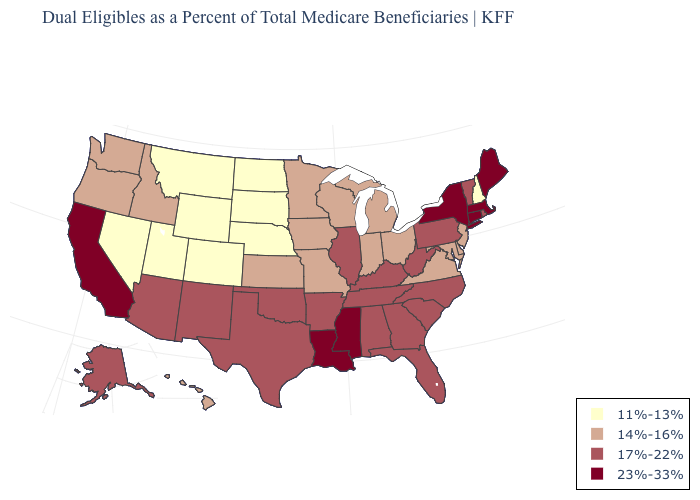Does North Carolina have a lower value than California?
Quick response, please. Yes. What is the value of Indiana?
Concise answer only. 14%-16%. Among the states that border Kansas , which have the lowest value?
Concise answer only. Colorado, Nebraska. Name the states that have a value in the range 17%-22%?
Answer briefly. Alabama, Alaska, Arizona, Arkansas, Florida, Georgia, Illinois, Kentucky, New Mexico, North Carolina, Oklahoma, Pennsylvania, Rhode Island, South Carolina, Tennessee, Texas, Vermont, West Virginia. What is the highest value in the Northeast ?
Short answer required. 23%-33%. What is the lowest value in the MidWest?
Short answer required. 11%-13%. Does New Hampshire have a lower value than Missouri?
Concise answer only. Yes. Which states have the highest value in the USA?
Write a very short answer. California, Connecticut, Louisiana, Maine, Massachusetts, Mississippi, New York. Does Idaho have the highest value in the USA?
Write a very short answer. No. Among the states that border Kansas , which have the lowest value?
Quick response, please. Colorado, Nebraska. Does Oklahoma have the same value as South Carolina?
Write a very short answer. Yes. What is the highest value in the USA?
Answer briefly. 23%-33%. Which states hav the highest value in the MidWest?
Give a very brief answer. Illinois. Does Delaware have a higher value than Utah?
Quick response, please. Yes. Name the states that have a value in the range 14%-16%?
Answer briefly. Delaware, Hawaii, Idaho, Indiana, Iowa, Kansas, Maryland, Michigan, Minnesota, Missouri, New Jersey, Ohio, Oregon, Virginia, Washington, Wisconsin. 